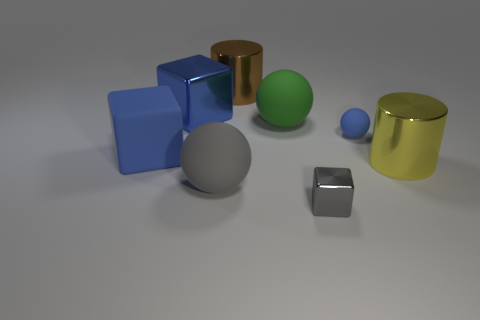How many green balls are the same size as the brown metal cylinder?
Your answer should be compact. 1. Do the sphere that is in front of the yellow metallic thing and the small sphere have the same material?
Offer a very short reply. Yes. Is the number of things to the right of the blue sphere less than the number of large rubber cylinders?
Ensure brevity in your answer.  No. What shape is the large blue object behind the green ball?
Give a very brief answer. Cube. There is a yellow thing that is the same size as the brown metallic cylinder; what shape is it?
Keep it short and to the point. Cylinder. Are there any gray metallic objects that have the same shape as the large yellow metallic thing?
Your answer should be very brief. No. Is the shape of the gray object on the left side of the brown object the same as the rubber thing to the right of the green thing?
Keep it short and to the point. Yes. What material is the other cylinder that is the same size as the yellow metallic cylinder?
Provide a short and direct response. Metal. What number of other objects are the same material as the green sphere?
Your response must be concise. 3. The object that is on the right side of the blue matte thing that is on the right side of the gray rubber thing is what shape?
Offer a terse response. Cylinder. 